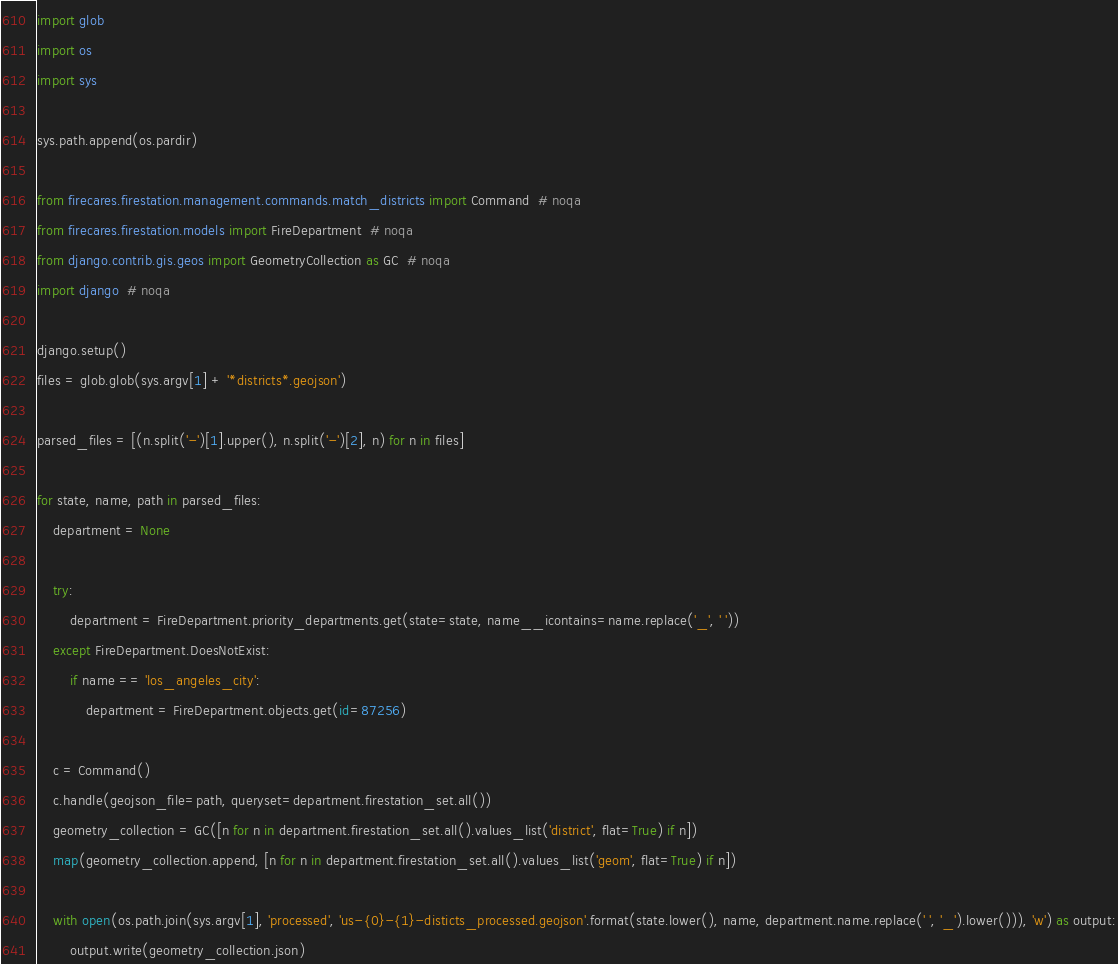Convert code to text. <code><loc_0><loc_0><loc_500><loc_500><_Python_>import glob
import os
import sys

sys.path.append(os.pardir)

from firecares.firestation.management.commands.match_districts import Command  # noqa
from firecares.firestation.models import FireDepartment  # noqa
from django.contrib.gis.geos import GeometryCollection as GC  # noqa
import django  # noqa

django.setup()
files = glob.glob(sys.argv[1] + '*districts*.geojson')

parsed_files = [(n.split('-')[1].upper(), n.split('-')[2], n) for n in files]

for state, name, path in parsed_files:
    department = None

    try:
        department = FireDepartment.priority_departments.get(state=state, name__icontains=name.replace('_', ' '))
    except FireDepartment.DoesNotExist:
        if name == 'los_angeles_city':
            department = FireDepartment.objects.get(id=87256)

    c = Command()
    c.handle(geojson_file=path, queryset=department.firestation_set.all())
    geometry_collection = GC([n for n in department.firestation_set.all().values_list('district', flat=True) if n])
    map(geometry_collection.append, [n for n in department.firestation_set.all().values_list('geom', flat=True) if n])

    with open(os.path.join(sys.argv[1], 'processed', 'us-{0}-{1}-disticts_processed.geojson'.format(state.lower(), name, department.name.replace(' ', '_').lower())), 'w') as output:
        output.write(geometry_collection.json)
</code> 